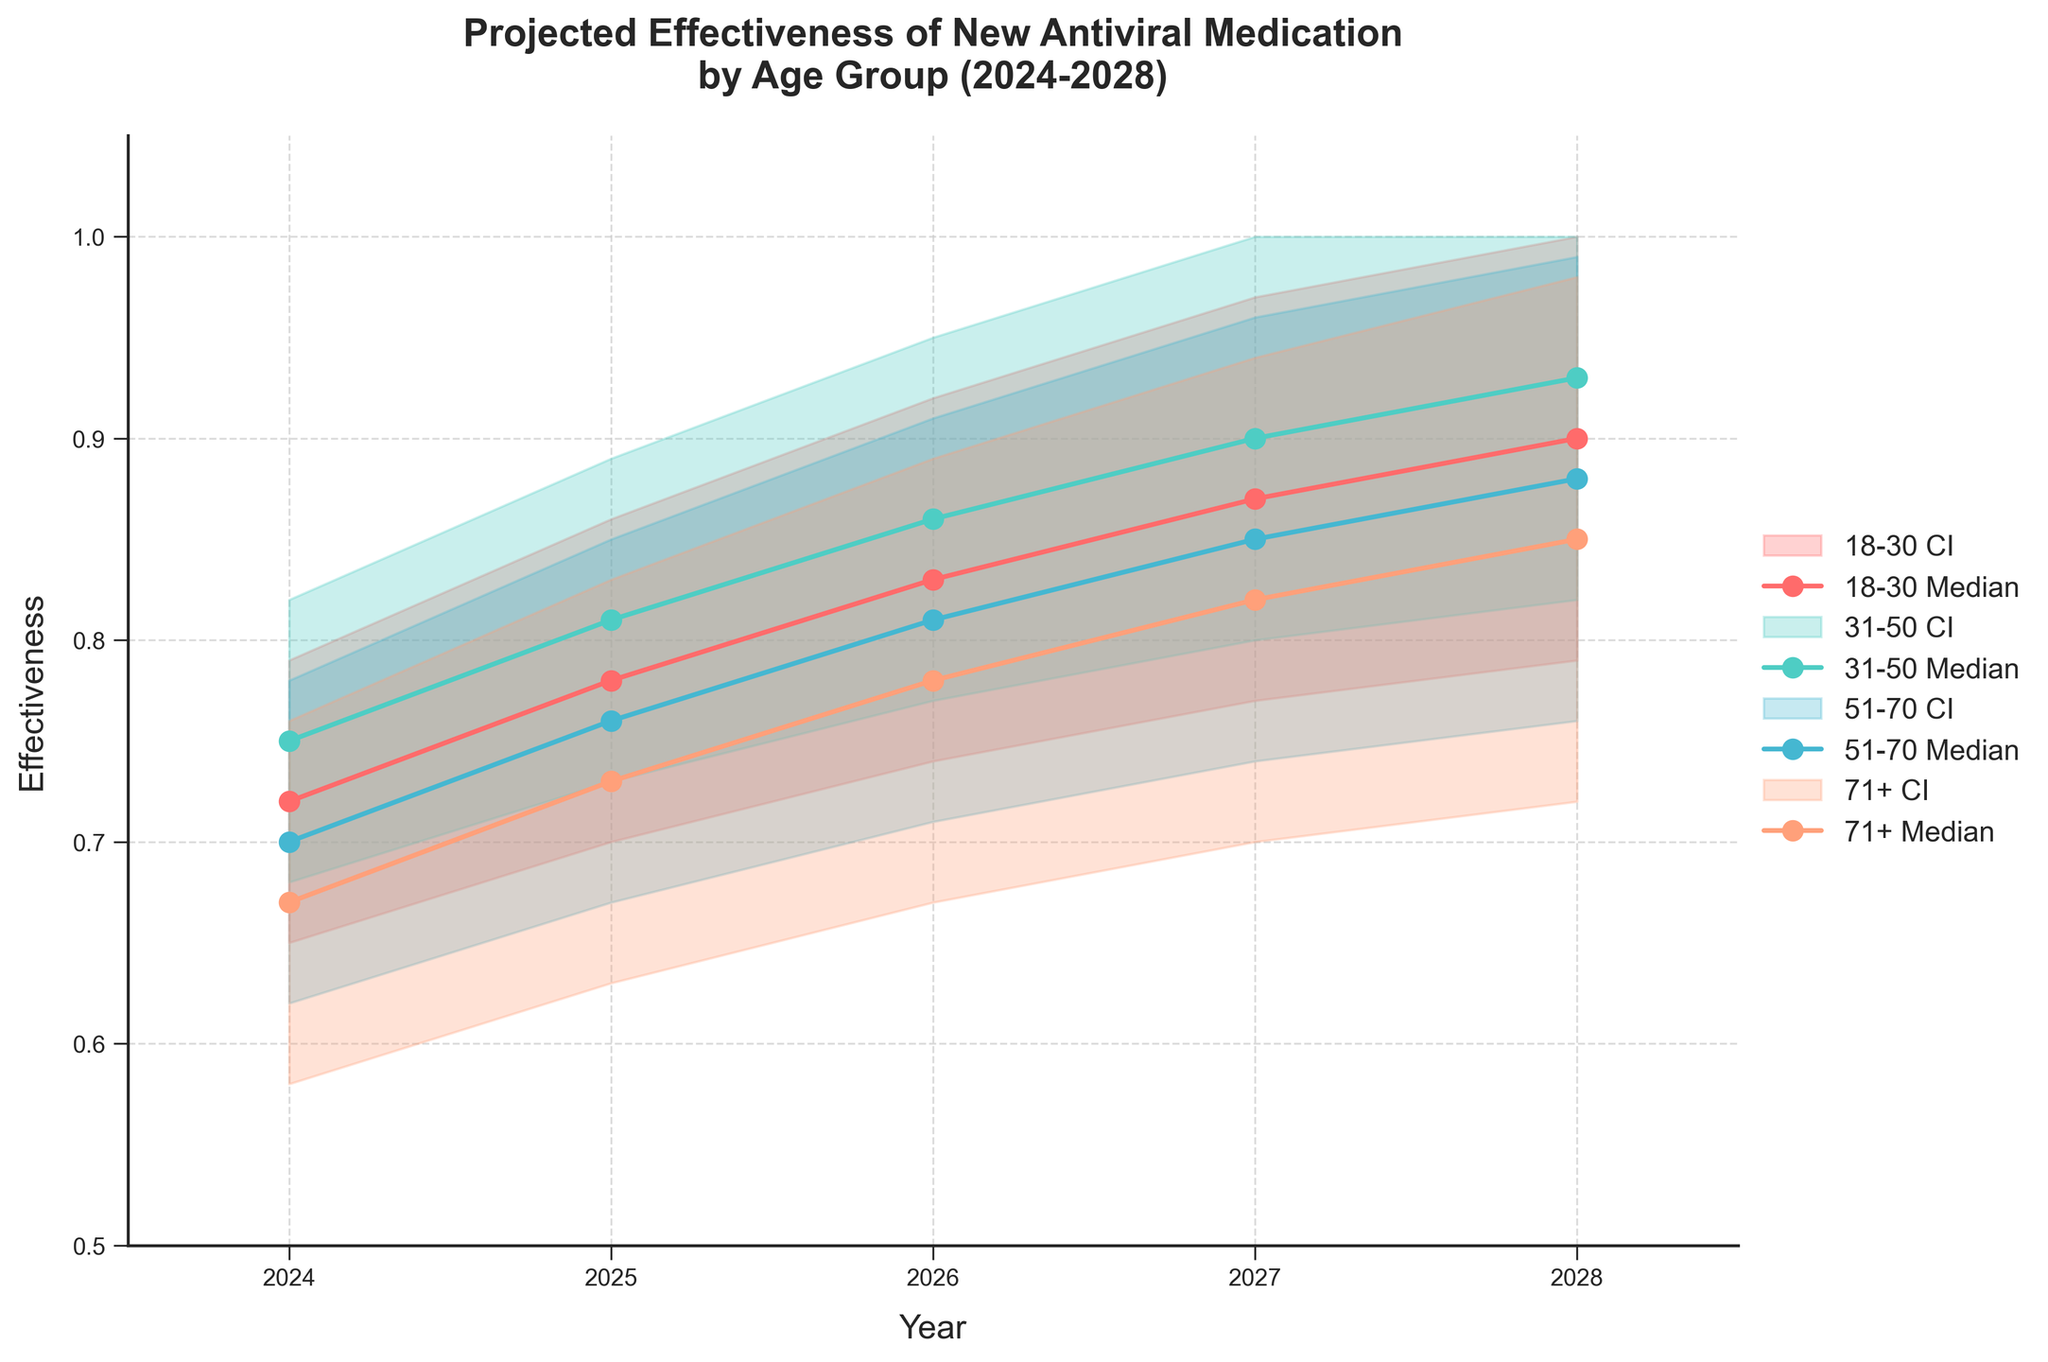Which age group has the highest median effectiveness in 2027? Check the median effectiveness values for each age group in 2027 and identify the highest one. 18-30: 0.87, 31-50: 0.90, 51-70: 0.85, 71+: 0.82. The highest value is for the 31-50 age group.
Answer: 31-50 What is the effectiveness range for the 18-30 age group in 2028? Check the lower and upper effectiveness bounds for the 18-30 age group in 2028. The effectiveness range is from 0.79 to 1.00.
Answer: 0.79-1.00 How does the median effectiveness for the 51-70 age group change from 2024 to 2028? Look at the median effectiveness values for the 51-70 age group from 2024 to 2028: 0.70 (2024), 0.76 (2025), 0.81 (2026), 0.85 (2027), 0.88 (2028). Compare these values year by year to track the change.
Answer: Increases Which age group shows the largest increase in median effectiveness from 2024 to 2028? Calculate the difference in median effectiveness from 2024 to 2028 for each age group: 18-30 (0.90-0.72=0.18), 31-50 (0.93-0.75=0.18), 51-70 (0.88-0.70=0.18), 71+ (0.85-0.67=0.18). Each group shows the same increase.
Answer: All equal (0.18) What is the overall trend in the effectiveness of the antiviral medication over time for the 71+ age group? Examine the median effectiveness values for the 71+ age group from 2024 to 2028: 0.67 (2024), 0.73 (2025), 0.78 (2026), 0.82 (2027), 0.85 (2028). Notice the upward trend over the years.
Answer: Increasing Which age group has the narrowest confidence interval in 2026? Calculate the confidence interval range (upper bound - lower bound) for each age group in 2026: 18-30 (0.92-0.74=0.18), 31-50 (0.95-0.77=0.18), 51-70 (0.91-0.71=0.20), 71+ (0.89-0.67=0.22). Find the narrowest range.
Answer: 18-30 and 31-50 Is the median effectiveness for the 31-50 age group in 2025 higher than that of the 18-30 age group in 2024? Compare the median effectiveness values: 31-50 age group in 2025: 0.81, 18-30 age group in 2024: 0.72. Confirm if the former is higher.
Answer: Yes Does the 71+ age group's median effectiveness ever surpass 0.80 between 2024 and 2028? Check the median effectiveness values for the 71+ age group from 2024 to 2028. The values are 0.67 (2024), 0.73 (2025), 0.78 (2026), 0.82 (2027), and 0.85 (2028). Notice the values exceed 0.80 starting in 2027.
Answer: Yes What year shows the highest overall effectiveness median across all age groups? Find the median effectiveness for all age groups for each year and identify the maximum median effectiveness: 
2024: max(0.72, 0.75, 0.70, 0.67) = 0.75
2025: max(0.78, 0.81, 0.76, 0.73) = 0.81
2026: max(0.83, 0.86, 0.81, 0.78) = 0.86
2027: max(0.87, 0.90, 0.85, 0.82) = 0.90
2028: max(0.90, 0.93, 0.88, 0.85) = 0.93
The highest median effectiveness is 0.93 in 2028.
Answer: 2028 